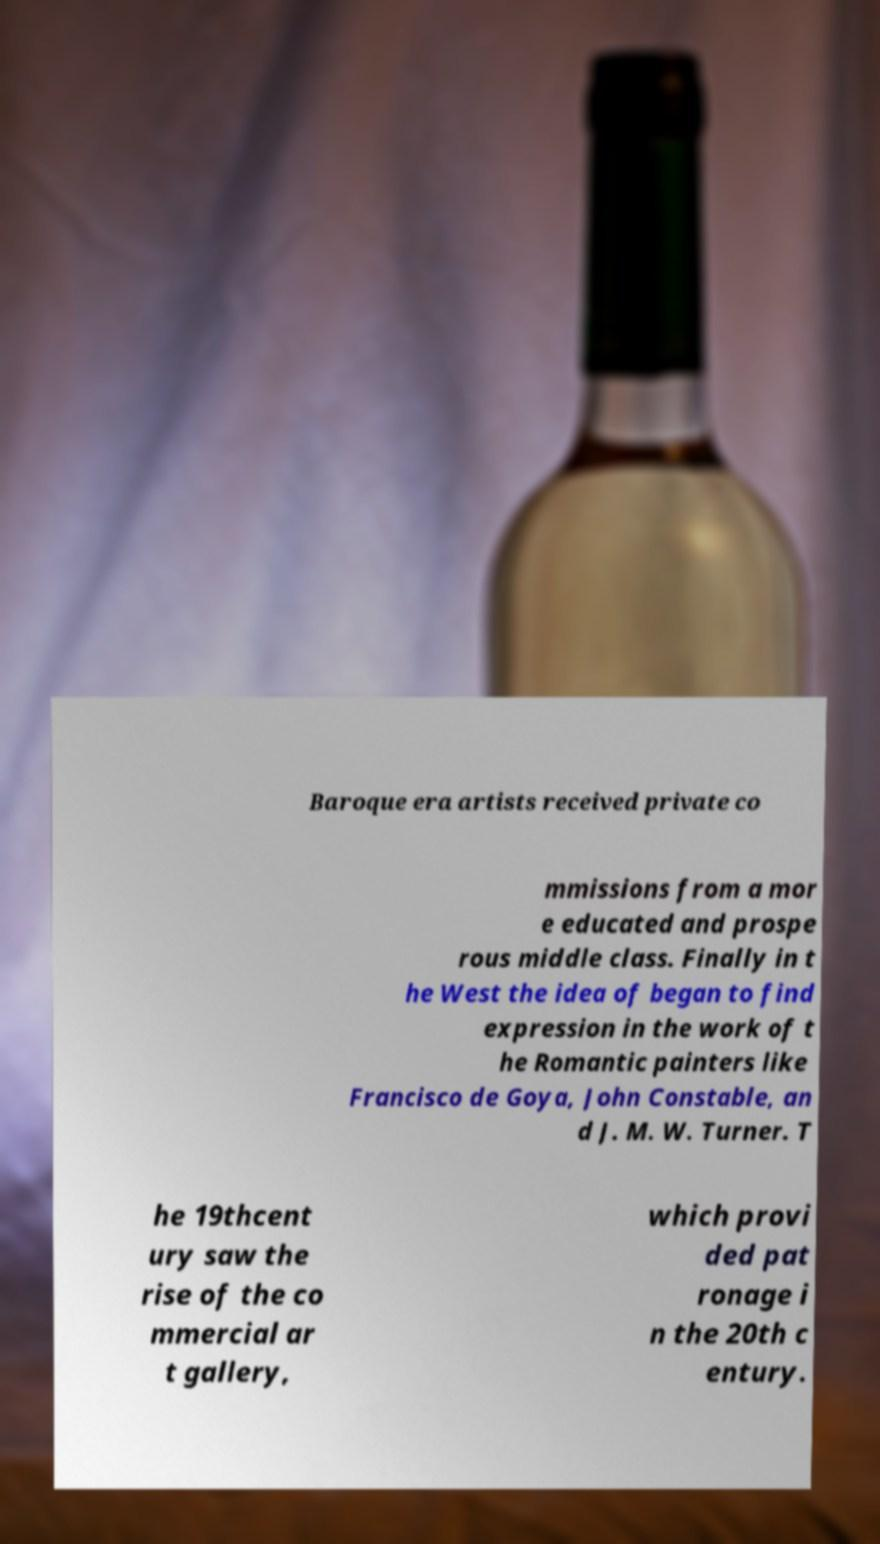Can you read and provide the text displayed in the image?This photo seems to have some interesting text. Can you extract and type it out for me? Baroque era artists received private co mmissions from a mor e educated and prospe rous middle class. Finally in t he West the idea of began to find expression in the work of t he Romantic painters like Francisco de Goya, John Constable, an d J. M. W. Turner. T he 19thcent ury saw the rise of the co mmercial ar t gallery, which provi ded pat ronage i n the 20th c entury. 